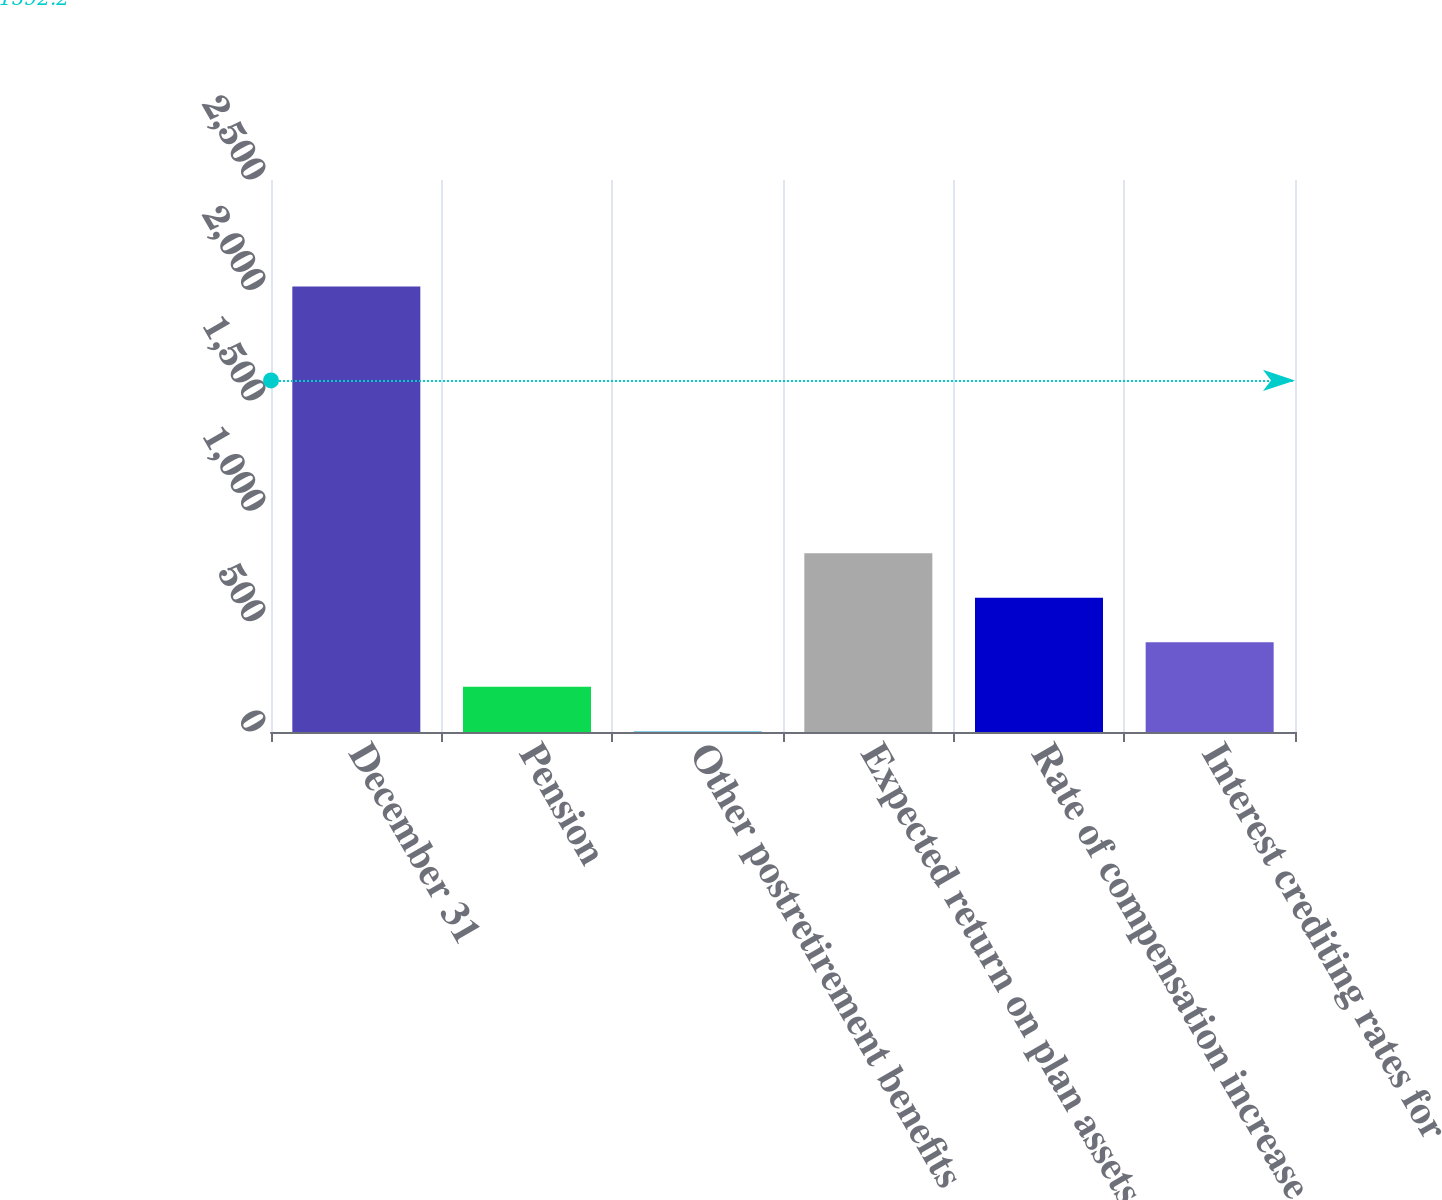Convert chart. <chart><loc_0><loc_0><loc_500><loc_500><bar_chart><fcel>December 31<fcel>Pension<fcel>Other postretirement benefits<fcel>Expected return on plan assets<fcel>Rate of compensation increase<fcel>Interest crediting rates for<nl><fcel>2018<fcel>205.4<fcel>4<fcel>809.6<fcel>608.2<fcel>406.8<nl></chart> 